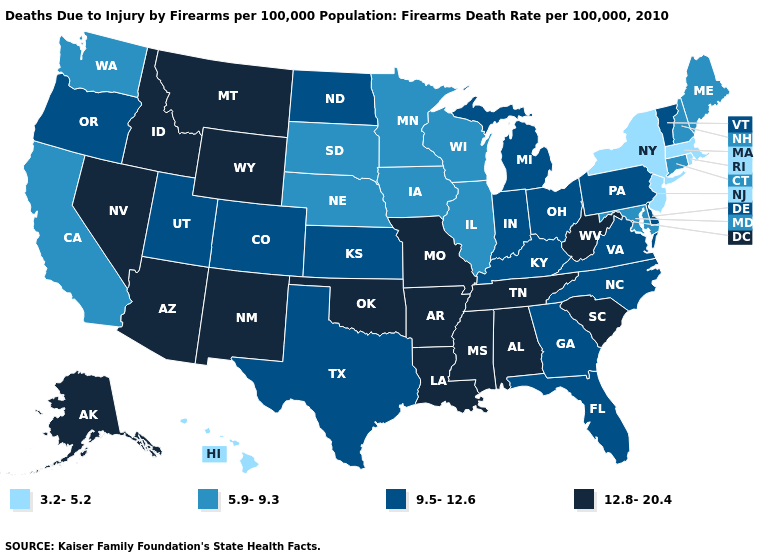Among the states that border Alabama , does Tennessee have the highest value?
Short answer required. Yes. Name the states that have a value in the range 12.8-20.4?
Write a very short answer. Alabama, Alaska, Arizona, Arkansas, Idaho, Louisiana, Mississippi, Missouri, Montana, Nevada, New Mexico, Oklahoma, South Carolina, Tennessee, West Virginia, Wyoming. Name the states that have a value in the range 5.9-9.3?
Keep it brief. California, Connecticut, Illinois, Iowa, Maine, Maryland, Minnesota, Nebraska, New Hampshire, South Dakota, Washington, Wisconsin. Among the states that border North Dakota , does Montana have the highest value?
Answer briefly. Yes. Does the first symbol in the legend represent the smallest category?
Write a very short answer. Yes. What is the highest value in states that border Montana?
Give a very brief answer. 12.8-20.4. Among the states that border Alabama , which have the highest value?
Quick response, please. Mississippi, Tennessee. Which states have the highest value in the USA?
Quick response, please. Alabama, Alaska, Arizona, Arkansas, Idaho, Louisiana, Mississippi, Missouri, Montana, Nevada, New Mexico, Oklahoma, South Carolina, Tennessee, West Virginia, Wyoming. Is the legend a continuous bar?
Write a very short answer. No. Does the map have missing data?
Quick response, please. No. What is the highest value in states that border Colorado?
Write a very short answer. 12.8-20.4. Does Hawaii have the same value as Massachusetts?
Be succinct. Yes. How many symbols are there in the legend?
Answer briefly. 4. Does the map have missing data?
Quick response, please. No. Name the states that have a value in the range 12.8-20.4?
Quick response, please. Alabama, Alaska, Arizona, Arkansas, Idaho, Louisiana, Mississippi, Missouri, Montana, Nevada, New Mexico, Oklahoma, South Carolina, Tennessee, West Virginia, Wyoming. 